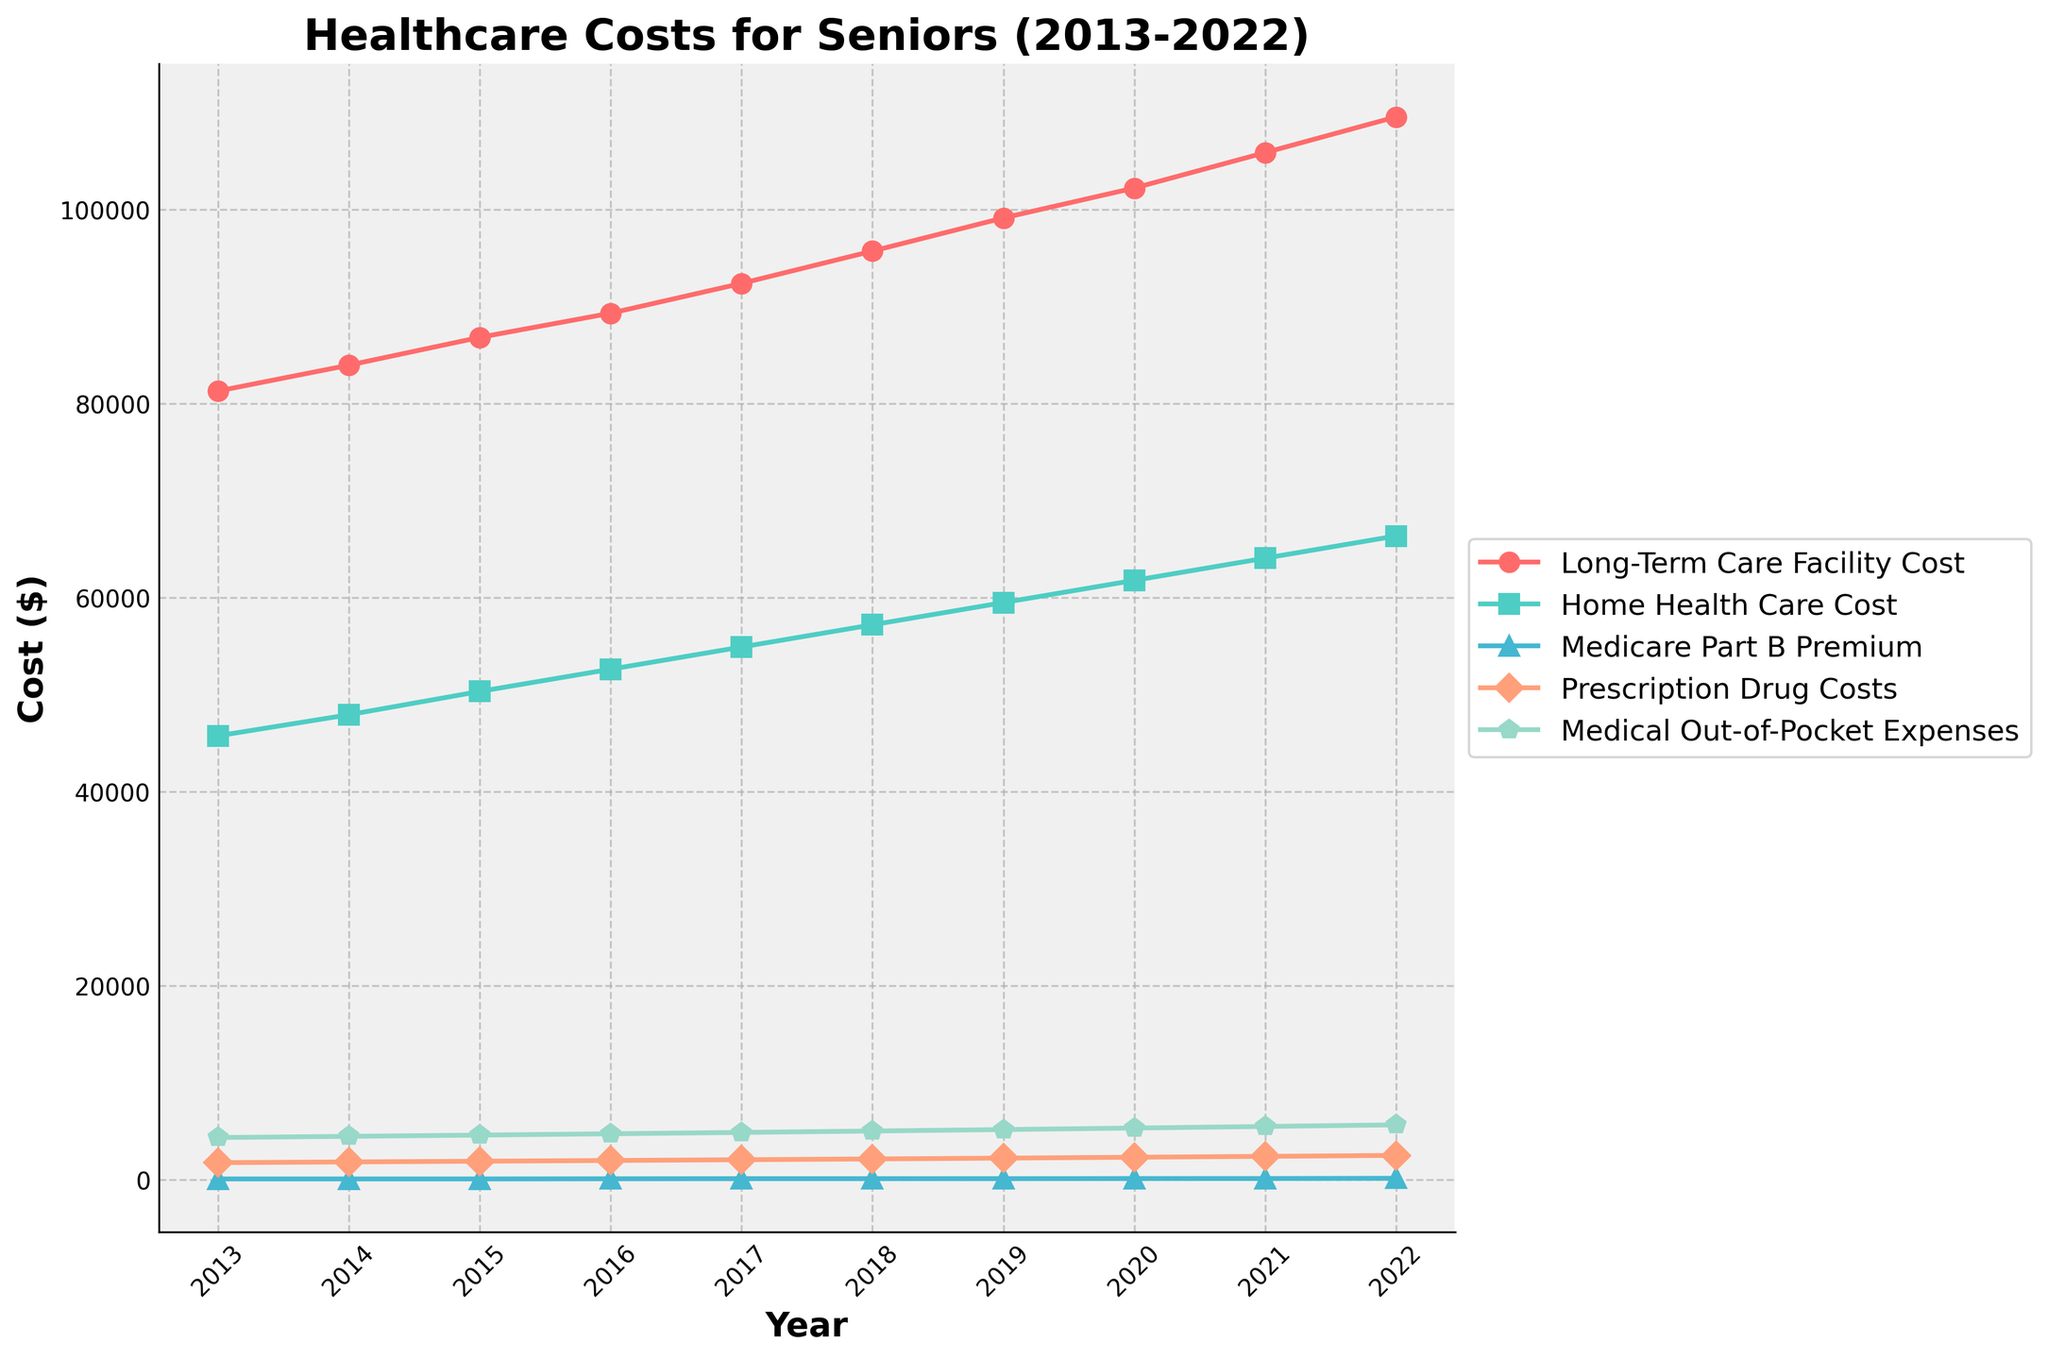What is the trend of Long-Term Care Facility Costs from 2013 to 2022? The Long-Term Care Facility Costs increase steadily from 2013 to 2022. Starting at $81,285 in 2013 and rising to $109,532 in 2022.
Answer: Increasing trend Which healthcare cost has the sharpest increase between 2019 and 2022? By looking at the slope of the lines from 2019 to 2022, Medicare Part B Premium shows the sharpest increase, going from $135.50 in 2019 to $170.10 in 2022.
Answer: Medicare Part B Premium What was the Home Health Care Cost in 2016, and how does it compare to 2022? The Home Health Care Cost in 2016 was $52,624. In 2022, it is $66,352. Calculating the difference gives $66,352 - $52,624 = $13,728.
Answer: $52,624 and $13,728 increase Which year saw the largest increase in Prescription Drug Costs? Observing the graph, the year with the most significant increase in Prescription Drug Costs is from 2017 to 2018, where the cost rose from $2,084 to $2,165.
Answer: 2017 to 2018 Which cost category exhibits the smallest increase over the decade? By comparing the initial and final values of each category over the decade, Medical Out-of-Pocket Expenses exhibit the smallest increase, going from $4,371 in 2013 to $5,679 in 2022, which is an increase of $1,308.
Answer: Medical Out-of-Pocket Expenses Compare the trend of Medical Out-of-Pocket Expenses to Home Health Care Costs. Medical Out-of-Pocket Expenses show a steady increase from $4,371 in 2013 to $5,679 in 2022. In contrast, Home Health Care Costs also increase steadily but from a much higher base, starting at $45,760 in 2013 and reaching $66,352 in 2022, which increases much more significantly in absolute terms.
Answer: Both increase, but Home Health Care Costs increase more What is the average cost of Medicare Part B Premium over the years displayed? Adding up the given Medicare Part B Premium values and dividing by the number of years yields: (104.90 + 104.90 + 104.90 + 121.80 + 134.00 + 134.00 + 135.50 + 144.60 + 148.50 + 170.10) / 10 = 130.92.
Answer: $130.92 In which year did the Long-Term Care Facility Cost first exceed $90,000? By locating where the Long-Term Care Facility Cost passes $90,000, we see that in 2017, the cost reaches $92,376.
Answer: 2017 